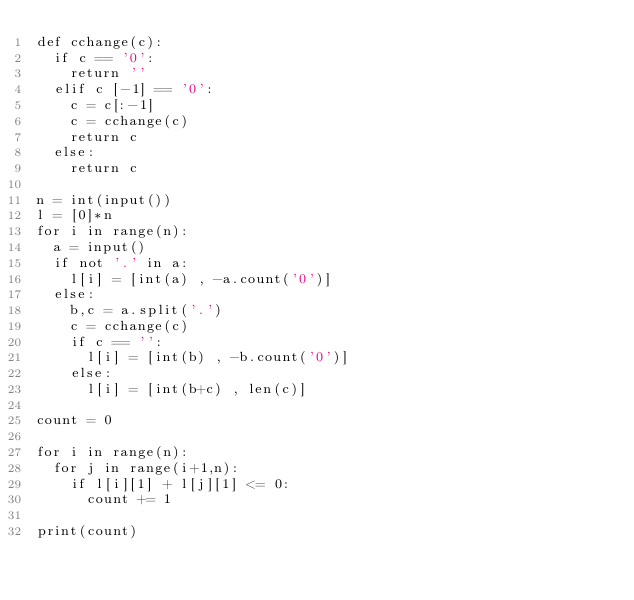Convert code to text. <code><loc_0><loc_0><loc_500><loc_500><_Python_>def cchange(c):
  if c == '0':
    return ''
  elif c [-1] == '0':
    c = c[:-1]
    c = cchange(c)
    return c
  else:
    return c

n = int(input())
l = [0]*n
for i in range(n):
  a = input()
  if not '.' in a:
    l[i] = [int(a) , -a.count('0')]
  else:
    b,c = a.split('.')
    c = cchange(c)
    if c == '':
      l[i] = [int(b) , -b.count('0')]
    else:
      l[i] = [int(b+c) , len(c)]

count = 0

for i in range(n):
  for j in range(i+1,n):
    if l[i][1] + l[j][1] <= 0:
      count += 1

print(count)</code> 